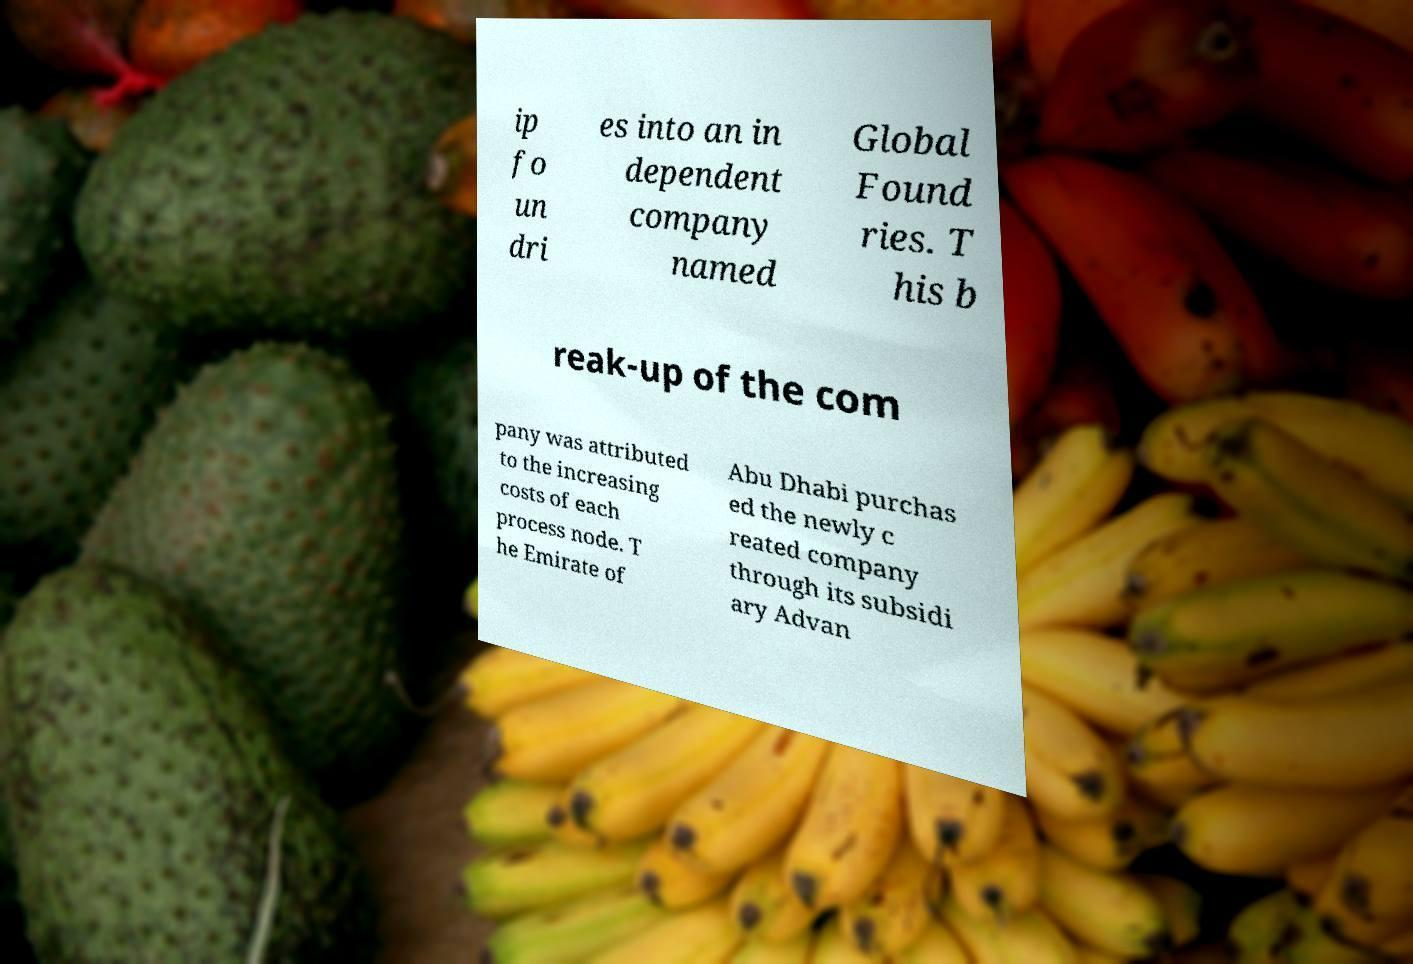Please identify and transcribe the text found in this image. ip fo un dri es into an in dependent company named Global Found ries. T his b reak-up of the com pany was attributed to the increasing costs of each process node. T he Emirate of Abu Dhabi purchas ed the newly c reated company through its subsidi ary Advan 